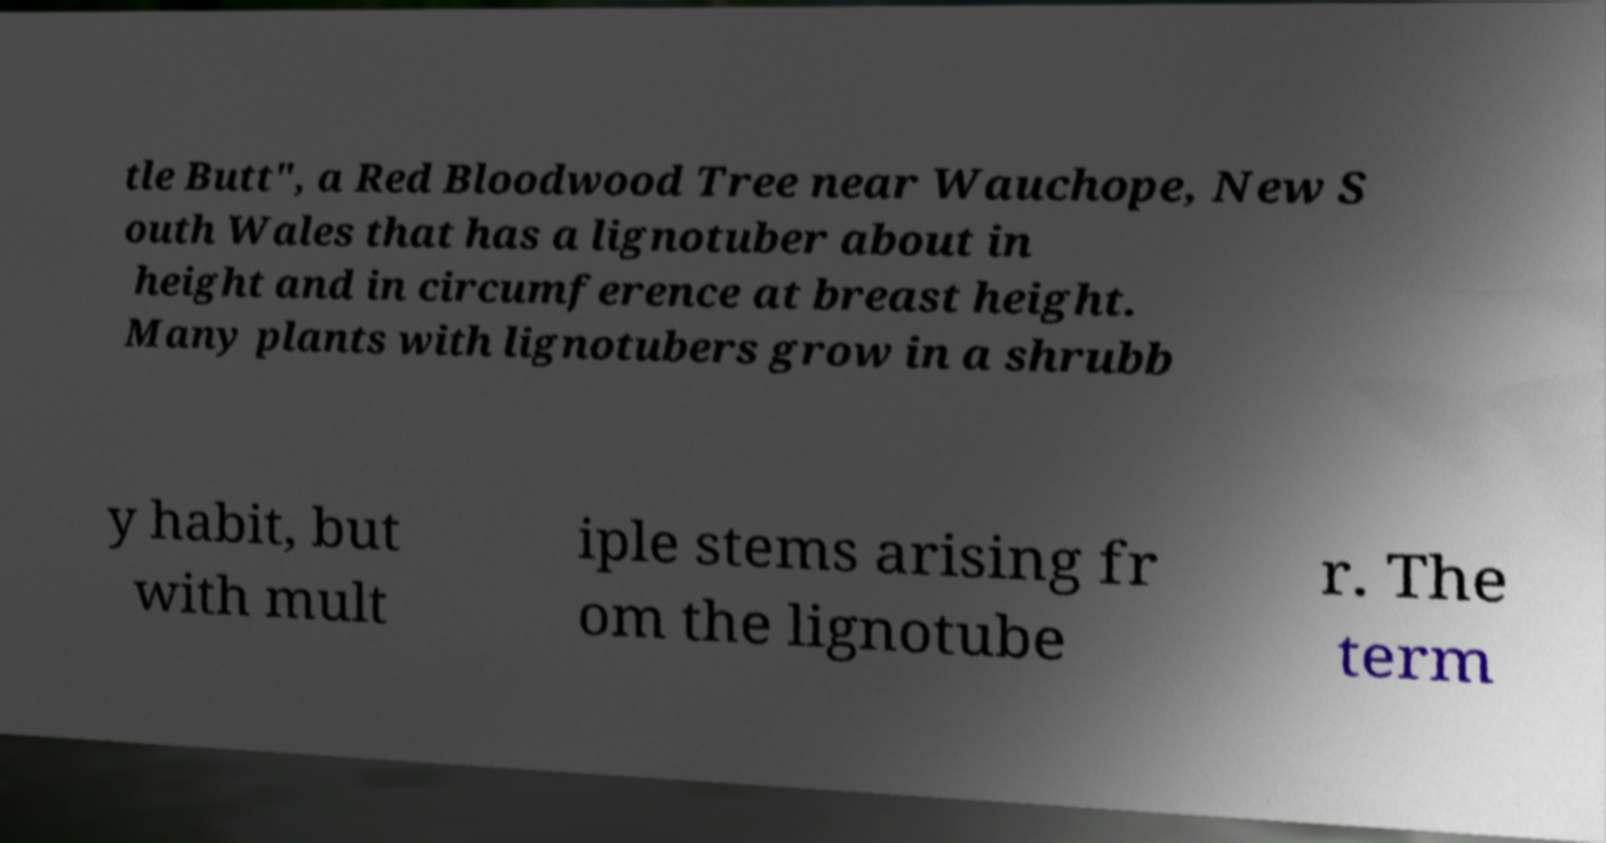Can you read and provide the text displayed in the image?This photo seems to have some interesting text. Can you extract and type it out for me? tle Butt", a Red Bloodwood Tree near Wauchope, New S outh Wales that has a lignotuber about in height and in circumference at breast height. Many plants with lignotubers grow in a shrubb y habit, but with mult iple stems arising fr om the lignotube r. The term 